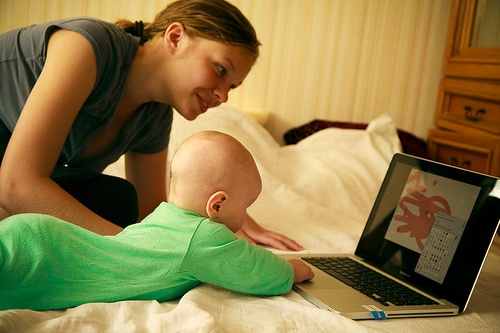Describe the objects in this image and their specific colors. I can see people in olive, black, brown, maroon, and tan tones, bed in olive and tan tones, people in olive, green, darkgreen, brown, and khaki tones, laptop in olive, black, maroon, and tan tones, and chair in olive, black, maroon, and brown tones in this image. 